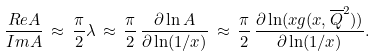Convert formula to latex. <formula><loc_0><loc_0><loc_500><loc_500>\frac { R e A } { I m A } \, \approx \, \frac { \pi } { 2 } \lambda \, \approx \, \frac { \pi } { 2 } \, \frac { \partial \ln A } { \partial \ln ( 1 / x ) } \, \approx \, \frac { \pi } { 2 } \, \frac { \partial \ln ( x g ( x , \overline { Q } ^ { 2 } ) ) } { \partial \ln ( 1 / x ) } .</formula> 